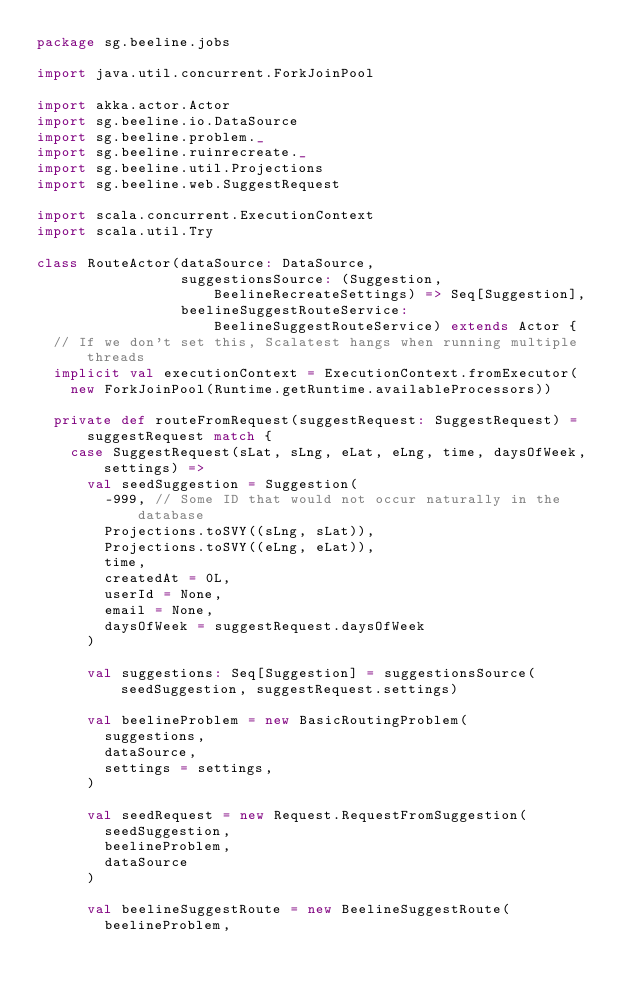Convert code to text. <code><loc_0><loc_0><loc_500><loc_500><_Scala_>package sg.beeline.jobs

import java.util.concurrent.ForkJoinPool

import akka.actor.Actor
import sg.beeline.io.DataSource
import sg.beeline.problem._
import sg.beeline.ruinrecreate._
import sg.beeline.util.Projections
import sg.beeline.web.SuggestRequest

import scala.concurrent.ExecutionContext
import scala.util.Try

class RouteActor(dataSource: DataSource,
                 suggestionsSource: (Suggestion, BeelineRecreateSettings) => Seq[Suggestion],
                 beelineSuggestRouteService: BeelineSuggestRouteService) extends Actor {
  // If we don't set this, Scalatest hangs when running multiple threads
  implicit val executionContext = ExecutionContext.fromExecutor(
    new ForkJoinPool(Runtime.getRuntime.availableProcessors))

  private def routeFromRequest(suggestRequest: SuggestRequest) = suggestRequest match {
    case SuggestRequest(sLat, sLng, eLat, eLng, time, daysOfWeek, settings) =>
      val seedSuggestion = Suggestion(
        -999, // Some ID that would not occur naturally in the database
        Projections.toSVY((sLng, sLat)),
        Projections.toSVY((eLng, eLat)),
        time,
        createdAt = 0L,
        userId = None,
        email = None,
        daysOfWeek = suggestRequest.daysOfWeek
      )

      val suggestions: Seq[Suggestion] = suggestionsSource(seedSuggestion, suggestRequest.settings)

      val beelineProblem = new BasicRoutingProblem(
        suggestions,
        dataSource,
        settings = settings,
      )

      val seedRequest = new Request.RequestFromSuggestion(
        seedSuggestion,
        beelineProblem,
        dataSource
      )

      val beelineSuggestRoute = new BeelineSuggestRoute(
        beelineProblem,</code> 